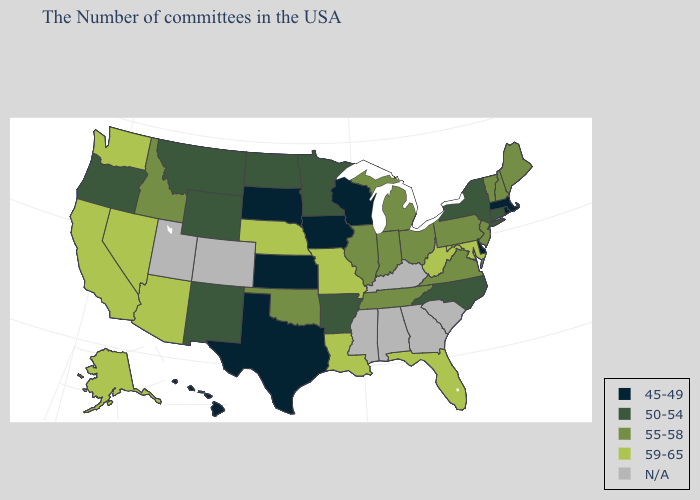What is the highest value in the USA?
Concise answer only. 59-65. What is the value of Montana?
Keep it brief. 50-54. Name the states that have a value in the range 59-65?
Give a very brief answer. Maryland, West Virginia, Florida, Louisiana, Missouri, Nebraska, Arizona, Nevada, California, Washington, Alaska. Does the map have missing data?
Keep it brief. Yes. Name the states that have a value in the range 55-58?
Give a very brief answer. Maine, New Hampshire, Vermont, New Jersey, Pennsylvania, Virginia, Ohio, Michigan, Indiana, Tennessee, Illinois, Oklahoma, Idaho. Name the states that have a value in the range N/A?
Be succinct. South Carolina, Georgia, Kentucky, Alabama, Mississippi, Colorado, Utah. Which states have the highest value in the USA?
Give a very brief answer. Maryland, West Virginia, Florida, Louisiana, Missouri, Nebraska, Arizona, Nevada, California, Washington, Alaska. What is the value of Oklahoma?
Short answer required. 55-58. Which states have the lowest value in the Northeast?
Be succinct. Massachusetts, Rhode Island. Name the states that have a value in the range 55-58?
Keep it brief. Maine, New Hampshire, Vermont, New Jersey, Pennsylvania, Virginia, Ohio, Michigan, Indiana, Tennessee, Illinois, Oklahoma, Idaho. What is the highest value in the Northeast ?
Concise answer only. 55-58. Name the states that have a value in the range 55-58?
Quick response, please. Maine, New Hampshire, Vermont, New Jersey, Pennsylvania, Virginia, Ohio, Michigan, Indiana, Tennessee, Illinois, Oklahoma, Idaho. Name the states that have a value in the range N/A?
Quick response, please. South Carolina, Georgia, Kentucky, Alabama, Mississippi, Colorado, Utah. What is the value of South Dakota?
Quick response, please. 45-49. 